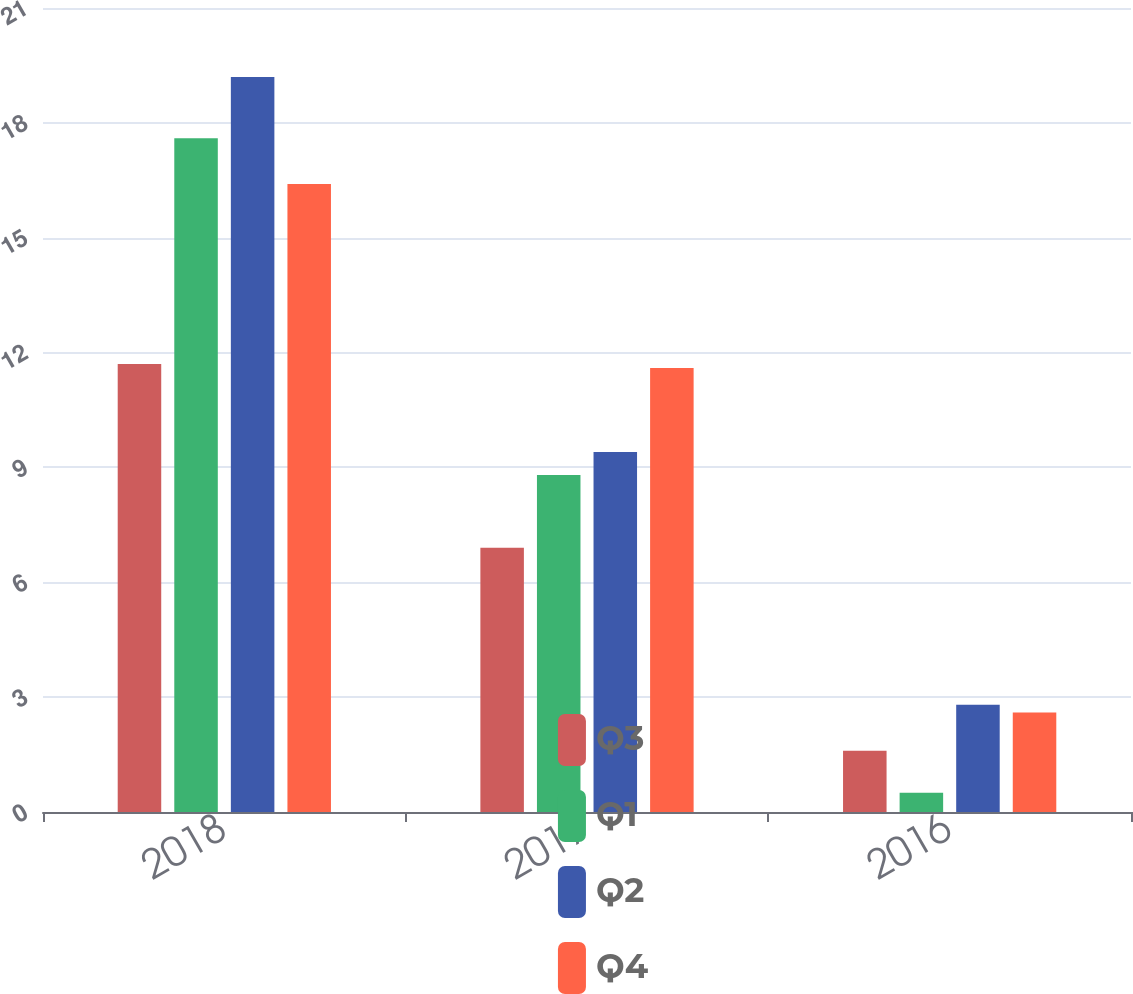Convert chart to OTSL. <chart><loc_0><loc_0><loc_500><loc_500><stacked_bar_chart><ecel><fcel>2018<fcel>2017<fcel>2016<nl><fcel>Q3<fcel>11.7<fcel>6.9<fcel>1.6<nl><fcel>Q1<fcel>17.6<fcel>8.8<fcel>0.5<nl><fcel>Q2<fcel>19.2<fcel>9.4<fcel>2.8<nl><fcel>Q4<fcel>16.4<fcel>11.6<fcel>2.6<nl></chart> 